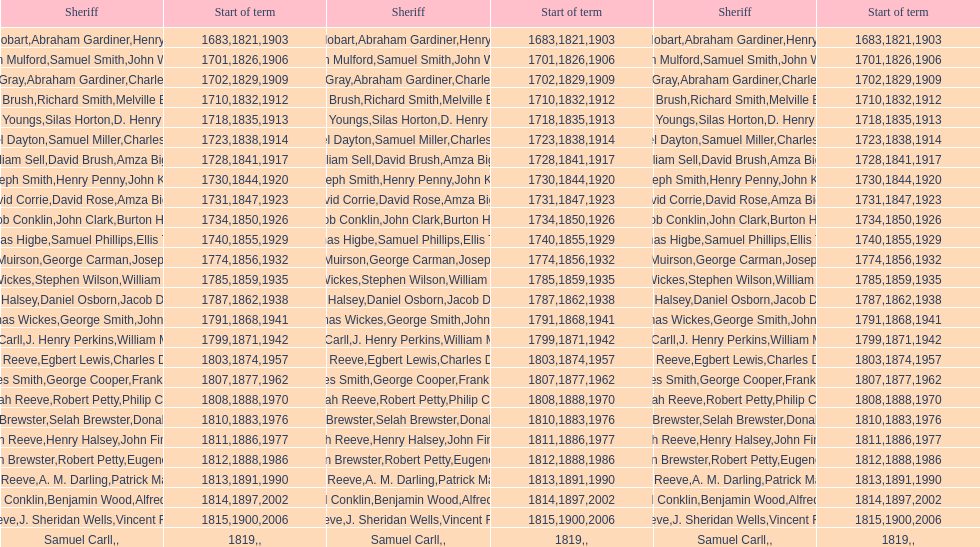What is the count of sheriffs who were in office in suffolk county during the years 1903 to 1957? 17. 